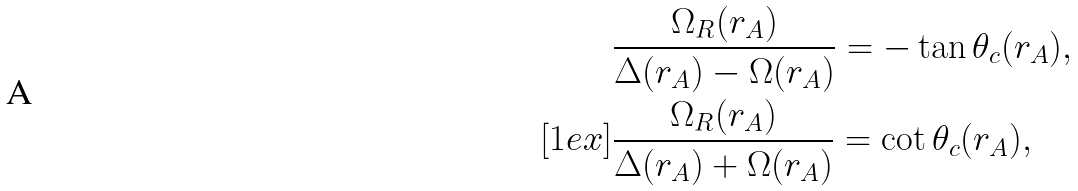<formula> <loc_0><loc_0><loc_500><loc_500>& \frac { \Omega _ { R } ( r _ { A } ) } { \Delta ( r _ { A } ) - \Omega ( r _ { A } ) } = - \tan \theta _ { c } ( r _ { A } ) , \\ [ 1 e x ] & \frac { \Omega _ { R } ( r _ { A } ) } { \Delta ( r _ { A } ) + \Omega ( r _ { A } ) } = \cot \theta _ { c } ( r _ { A } ) ,</formula> 